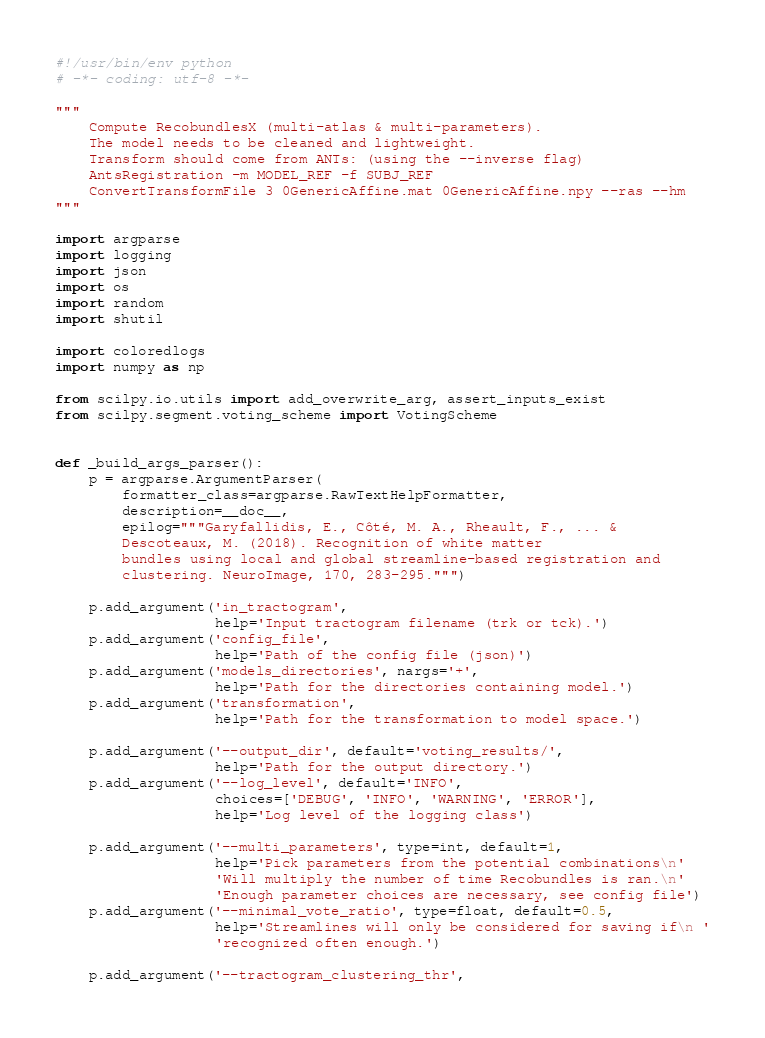Convert code to text. <code><loc_0><loc_0><loc_500><loc_500><_Python_>#!/usr/bin/env python
# -*- coding: utf-8 -*-

"""
    Compute RecobundlesX (multi-atlas & multi-parameters).
    The model needs to be cleaned and lightweight.
    Transform should come from ANTs: (using the --inverse flag)
    AntsRegistration -m MODEL_REF -f SUBJ_REF
    ConvertTransformFile 3 0GenericAffine.mat 0GenericAffine.npy --ras --hm
"""

import argparse
import logging
import json
import os
import random
import shutil

import coloredlogs
import numpy as np

from scilpy.io.utils import add_overwrite_arg, assert_inputs_exist
from scilpy.segment.voting_scheme import VotingScheme


def _build_args_parser():
    p = argparse.ArgumentParser(
        formatter_class=argparse.RawTextHelpFormatter,
        description=__doc__,
        epilog="""Garyfallidis, E., Côté, M. A., Rheault, F., ... &
        Descoteaux, M. (2018). Recognition of white matter
        bundles using local and global streamline-based registration and
        clustering. NeuroImage, 170, 283-295.""")

    p.add_argument('in_tractogram',
                   help='Input tractogram filename (trk or tck).')
    p.add_argument('config_file',
                   help='Path of the config file (json)')
    p.add_argument('models_directories', nargs='+',
                   help='Path for the directories containing model.')
    p.add_argument('transformation',
                   help='Path for the transformation to model space.')

    p.add_argument('--output_dir', default='voting_results/',
                   help='Path for the output directory.')
    p.add_argument('--log_level', default='INFO',
                   choices=['DEBUG', 'INFO', 'WARNING', 'ERROR'],
                   help='Log level of the logging class')

    p.add_argument('--multi_parameters', type=int, default=1,
                   help='Pick parameters from the potential combinations\n'
                   'Will multiply the number of time Recobundles is ran.\n'
                   'Enough parameter choices are necessary, see config file')
    p.add_argument('--minimal_vote_ratio', type=float, default=0.5,
                   help='Streamlines will only be considered for saving if\n '
                   'recognized often enough.')

    p.add_argument('--tractogram_clustering_thr',</code> 